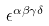Convert formula to latex. <formula><loc_0><loc_0><loc_500><loc_500>\epsilon ^ { \alpha \beta \gamma \delta }</formula> 